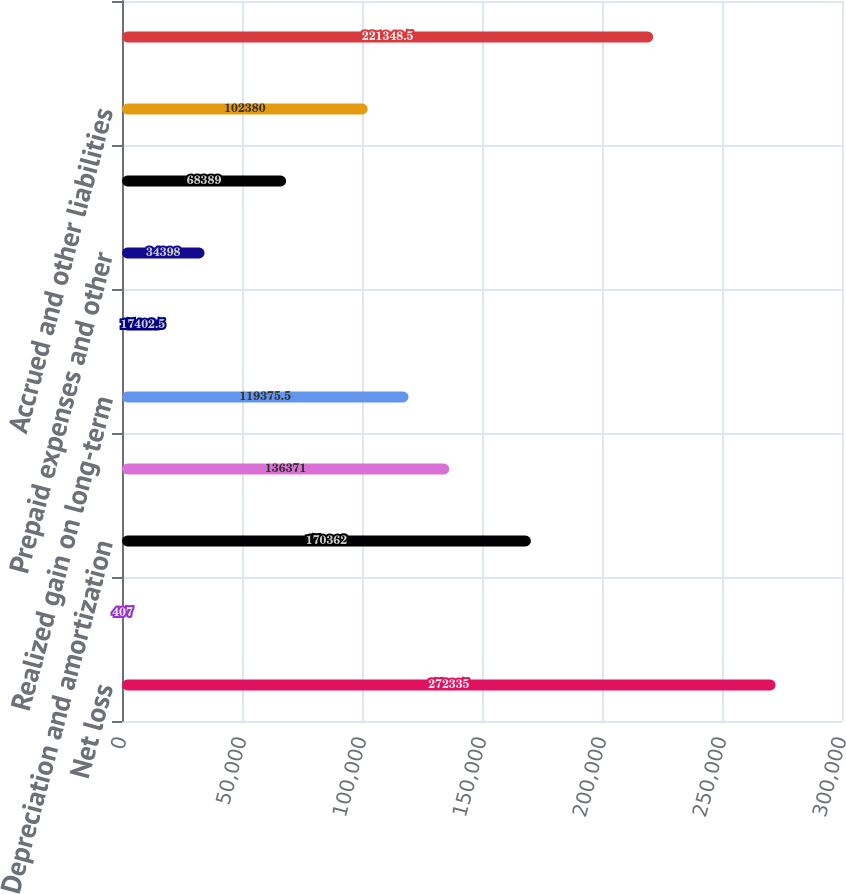<chart> <loc_0><loc_0><loc_500><loc_500><bar_chart><fcel>Net loss<fcel>Non-cash restructuring charges<fcel>Depreciation and amortization<fcel>Stock-based compensation<fcel>Realized gain on long-term<fcel>Accounts receivable<fcel>Prepaid expenses and other<fcel>Accounts payable<fcel>Accrued and other liabilities<fcel>Deferred revenue<nl><fcel>272335<fcel>407<fcel>170362<fcel>136371<fcel>119376<fcel>17402.5<fcel>34398<fcel>68389<fcel>102380<fcel>221348<nl></chart> 